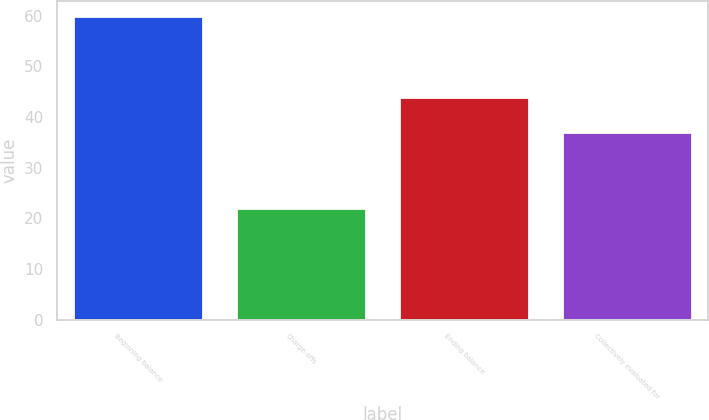Convert chart. <chart><loc_0><loc_0><loc_500><loc_500><bar_chart><fcel>Beginning balance<fcel>Charge-offs<fcel>Ending balance<fcel>Collectively evaluated for<nl><fcel>60<fcel>22<fcel>44<fcel>37<nl></chart> 